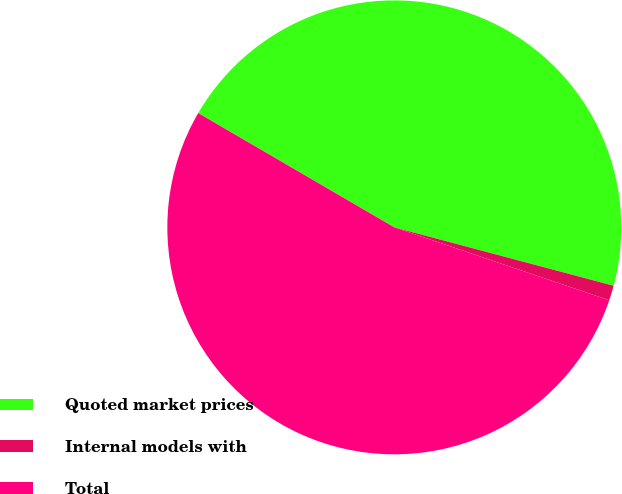Convert chart to OTSL. <chart><loc_0><loc_0><loc_500><loc_500><pie_chart><fcel>Quoted market prices<fcel>Internal models with<fcel>Total<nl><fcel>45.74%<fcel>1.06%<fcel>53.19%<nl></chart> 